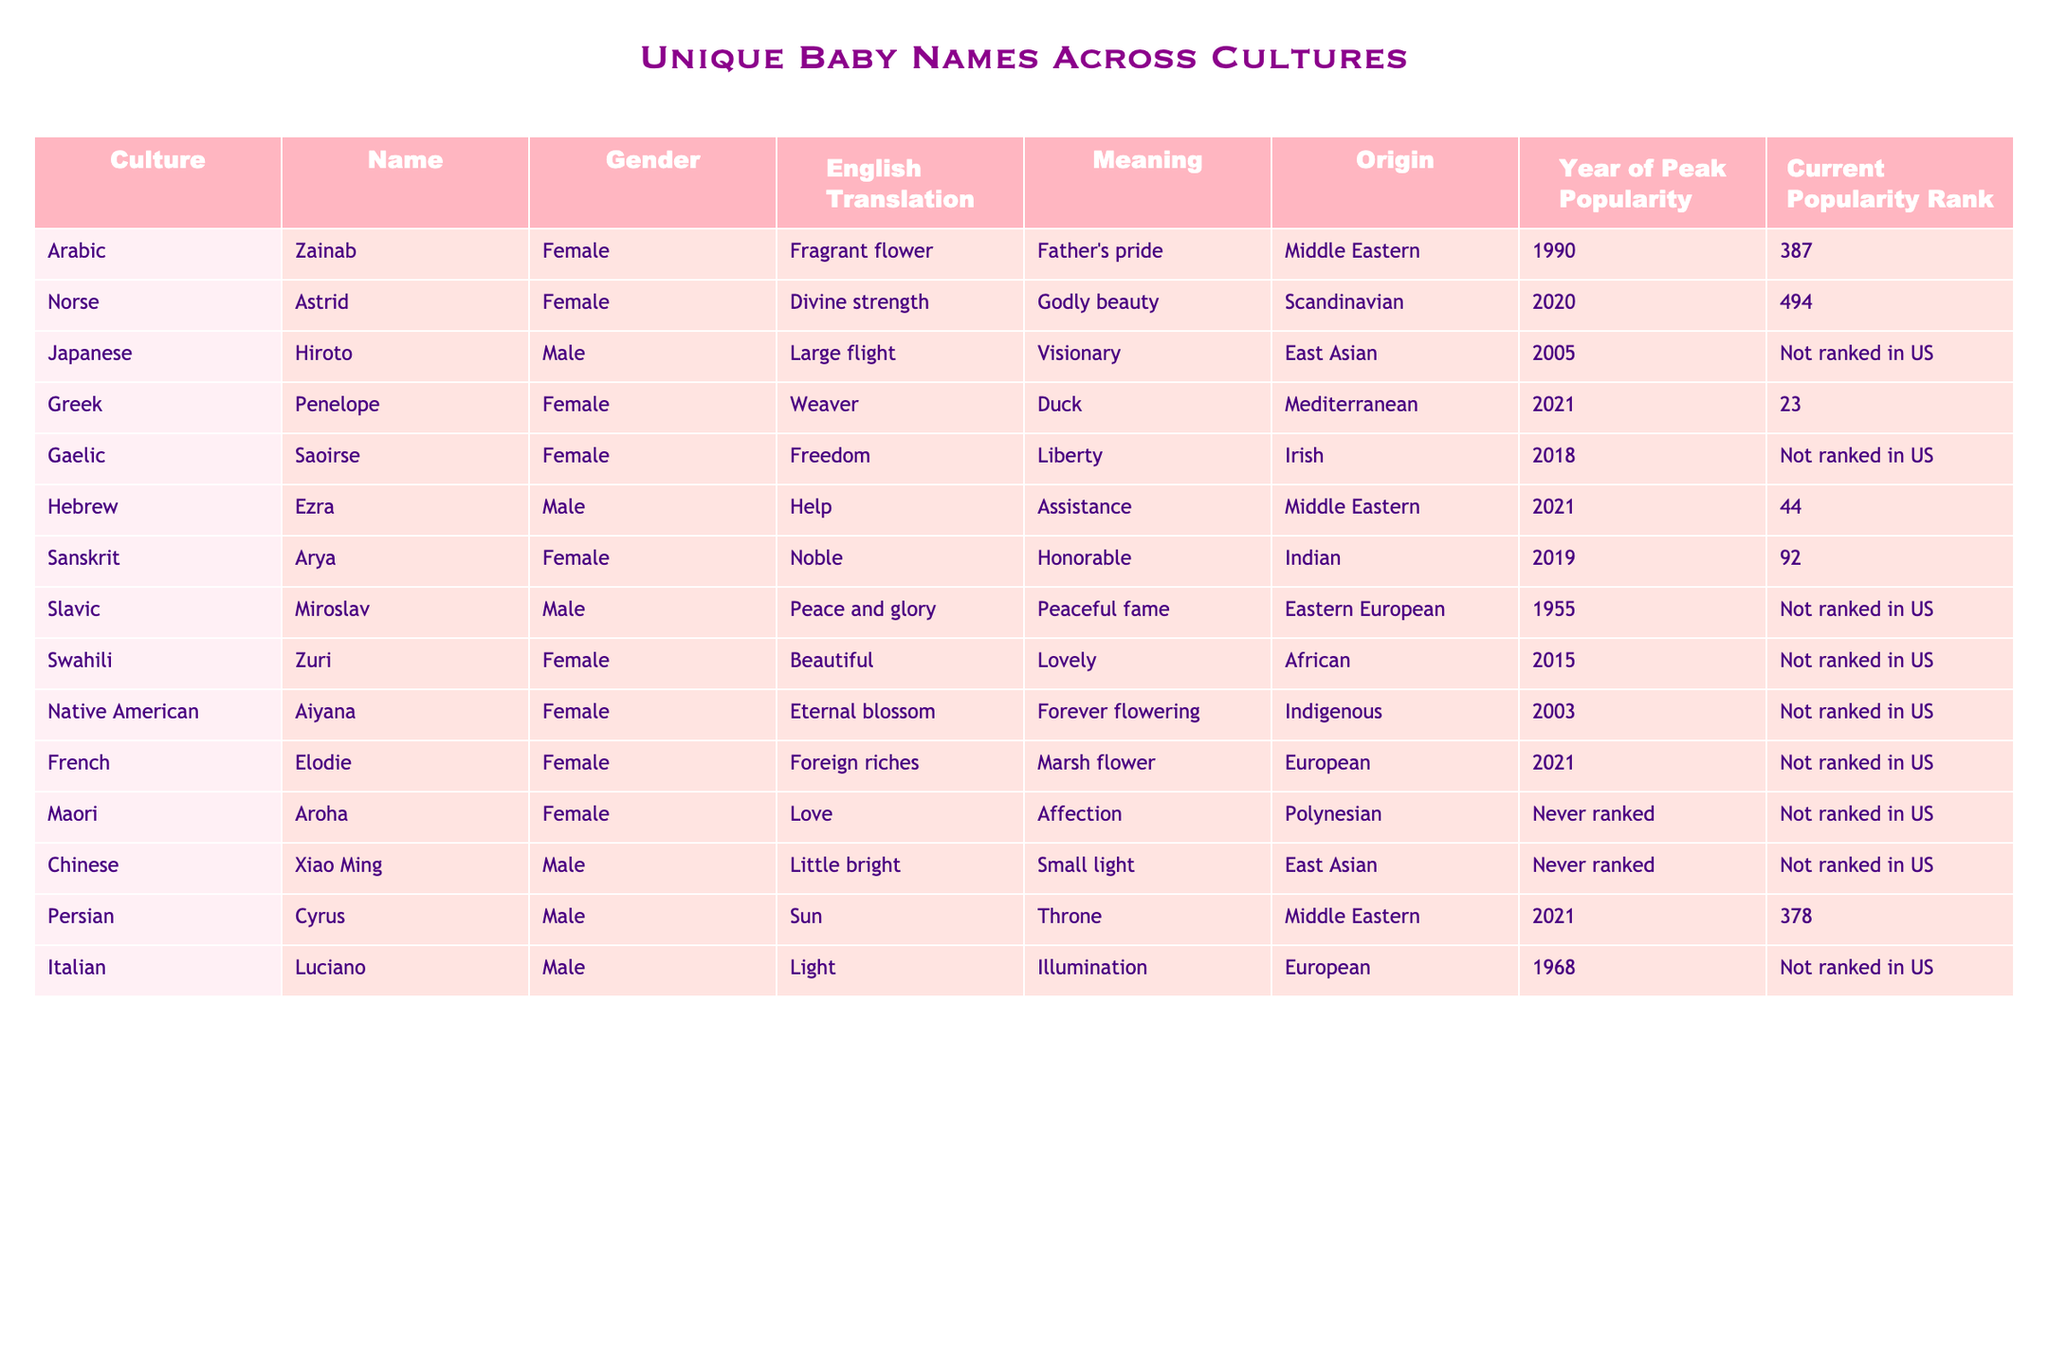What is the English translation of the name "Ezra"? The table shows that the English translation of the name "Ezra" is "Help."
Answer: Help Which culture does the name "Aroha" originate from? According to the table, "Aroha" is listed under the Maori culture.
Answer: Maori Is "Saoirse" ranked in the current popularity list in the US? The table indicates that "Saoirse" is not ranked in the current popularity list in the US, as shown in the corresponding column.
Answer: No What is the meaning of the name "Zuri"? The table provides that the meaning of "Zuri" is "Beautiful." Therefore, we can directly refer to that row in the table.
Answer: Beautiful How many unique names listed have an English translation that includes "flower"? The names "Zainab" and "Aiyana" have translations that include "flower," making a total of two names.
Answer: 2 Which name has the highest current popularity rank among the female names listed? Looking at the current popularity ranks for female names, "Penelope" has the highest current rank at 23.
Answer: 23 Is there a male name in the table with a current popularity rank of 378? Yes, the table indicates that the name "Cyrus" has a current popularity rank of 378.
Answer: Yes What is the average current popularity rank of the names that are ranked in the table? The current popularity ranks of ranked names are 387, 494, 44, 92, 378. Summing these gives 1395, dividing by 5 yields an average of 279.
Answer: 279 Which culture has a name with a meaning related to "liberty"? The table shows that the name "Saoirse" from the Gaelic culture has the meaning related to "liberty."
Answer: Gaelic What is the origin of the name "Hiroto"? Referring to the table, "Hiroto" originates from East Asia.
Answer: East Asian Is there any name that has never been ranked in the current popularity list in the US? Yes, the names "Aroha" and "Xiao Ming" are mentioned in the table as never ranked in the current popularity list.
Answer: Yes 